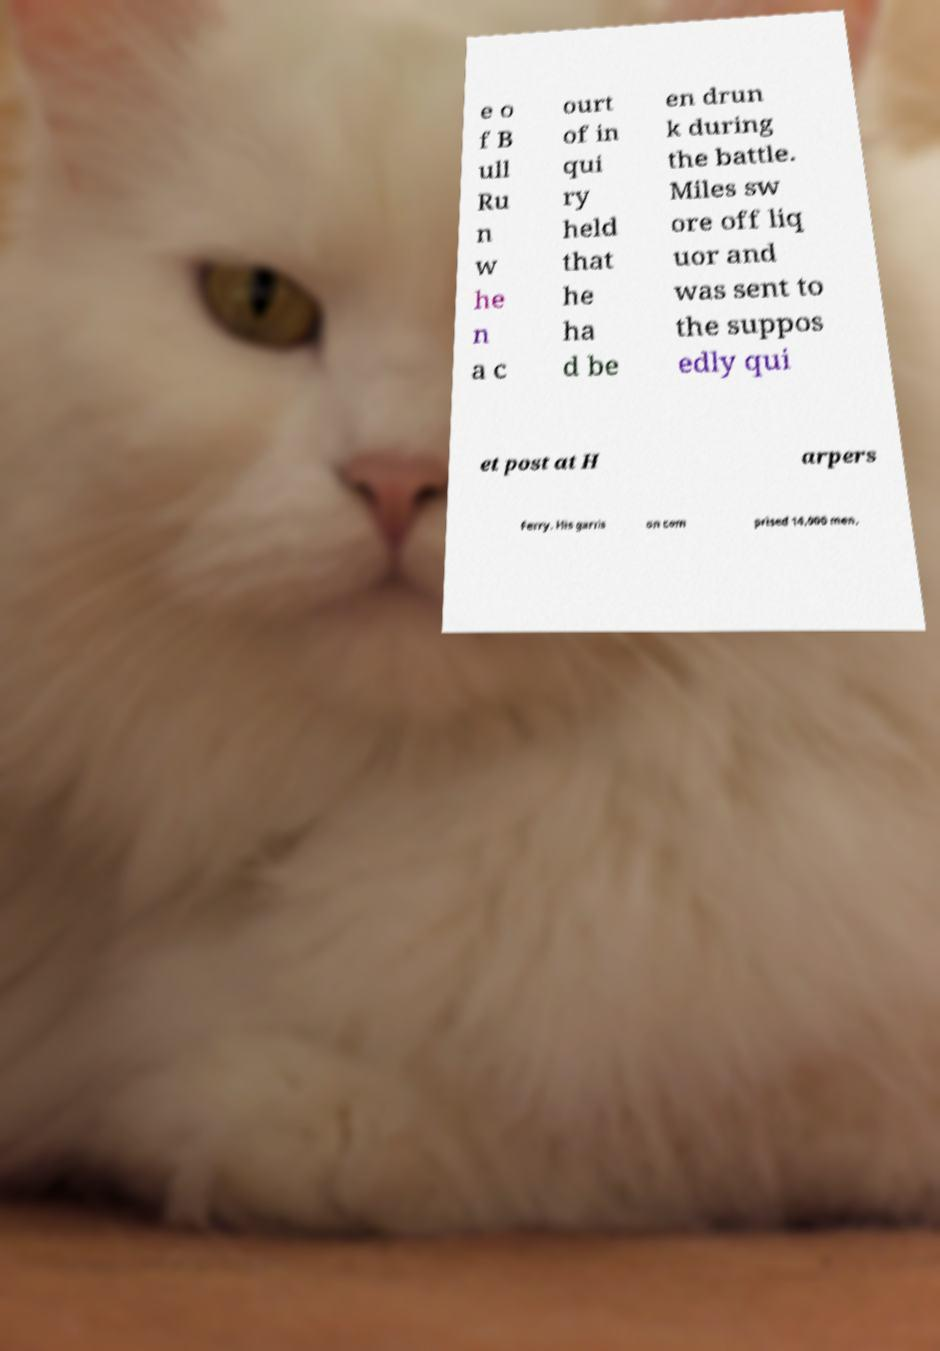Please read and relay the text visible in this image. What does it say? e o f B ull Ru n w he n a c ourt of in qui ry held that he ha d be en drun k during the battle. Miles sw ore off liq uor and was sent to the suppos edly qui et post at H arpers Ferry. His garris on com prised 14,000 men, 